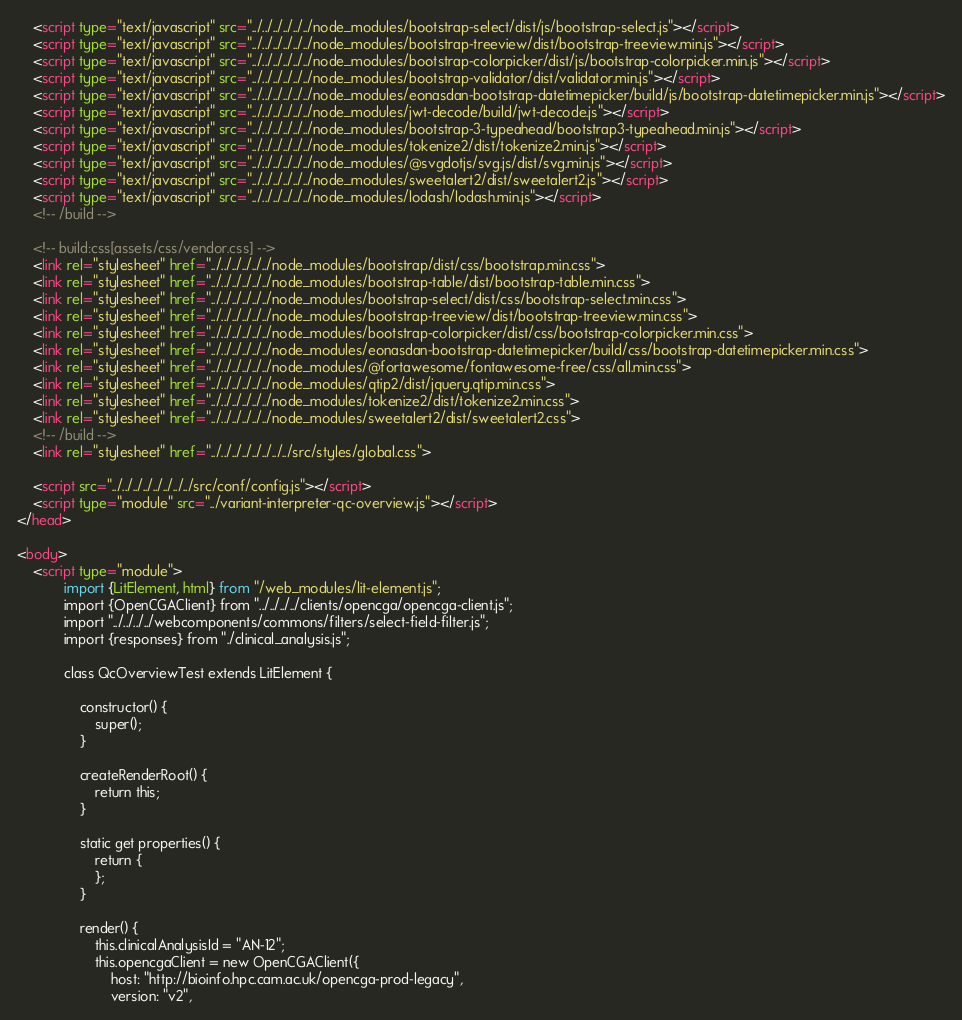Convert code to text. <code><loc_0><loc_0><loc_500><loc_500><_HTML_>    <script type="text/javascript" src="../../../../../../node_modules/bootstrap-select/dist/js/bootstrap-select.js"></script>
    <script type="text/javascript" src="../../../../../../node_modules/bootstrap-treeview/dist/bootstrap-treeview.min.js"></script>
    <script type="text/javascript" src="../../../../../../node_modules/bootstrap-colorpicker/dist/js/bootstrap-colorpicker.min.js"></script>
    <script type="text/javascript" src="../../../../../../node_modules/bootstrap-validator/dist/validator.min.js"></script>
    <script type="text/javascript" src="../../../../../../node_modules/eonasdan-bootstrap-datetimepicker/build/js/bootstrap-datetimepicker.min.js"></script>
    <script type="text/javascript" src="../../../../../../node_modules/jwt-decode/build/jwt-decode.js"></script>
    <script type="text/javascript" src="../../../../../../node_modules/bootstrap-3-typeahead/bootstrap3-typeahead.min.js"></script>
    <script type="text/javascript" src="../../../../../../node_modules/tokenize2/dist/tokenize2.min.js"></script>
    <script type="text/javascript" src="../../../../../../node_modules/@svgdotjs/svg.js/dist/svg.min.js"></script>
    <script type="text/javascript" src="../../../../../../node_modules/sweetalert2/dist/sweetalert2.js"></script>
    <script type="text/javascript" src="../../../../../../node_modules/lodash/lodash.min.js"></script>
    <!-- /build -->

    <!-- build:css[assets/css/vendor.css] -->
    <link rel="stylesheet" href="../../../../../../node_modules/bootstrap/dist/css/bootstrap.min.css">
    <link rel="stylesheet" href="../../../../../../node_modules/bootstrap-table/dist/bootstrap-table.min.css">
    <link rel="stylesheet" href="../../../../../../node_modules/bootstrap-select/dist/css/bootstrap-select.min.css">
    <link rel="stylesheet" href="../../../../../../node_modules/bootstrap-treeview/dist/bootstrap-treeview.min.css">
    <link rel="stylesheet" href="../../../../../../node_modules/bootstrap-colorpicker/dist/css/bootstrap-colorpicker.min.css">
    <link rel="stylesheet" href="../../../../../../node_modules/eonasdan-bootstrap-datetimepicker/build/css/bootstrap-datetimepicker.min.css">
    <link rel="stylesheet" href="../../../../../../node_modules/@fortawesome/fontawesome-free/css/all.min.css">
    <link rel="stylesheet" href="../../../../../../node_modules/qtip2/dist/jquery.qtip.min.css">
    <link rel="stylesheet" href="../../../../../../node_modules/tokenize2/dist/tokenize2.min.css">
    <link rel="stylesheet" href="../../../../../../node_modules/sweetalert2/dist/sweetalert2.css">
    <!-- /build -->
    <link rel="stylesheet" href="../../../../../../../../src/styles/global.css">

    <script src="../../../../../../../../src/conf/config.js"></script>
    <script type="module" src="../variant-interpreter-qc-overview.js"></script>
</head>

<body>
    <script type="module">
            import {LitElement, html} from "/web_modules/lit-element.js";
            import {OpenCGAClient} from "../../../../clients/opencga/opencga-client.js";
            import "../../../../webcomponents/commons/filters/select-field-filter.js";
            import {responses} from "./clinical_analysis.js";

            class QcOverviewTest extends LitElement {

                constructor() {
                    super();
                }

                createRenderRoot() {
                    return this;
                }

                static get properties() {
                    return {
                    };
                }

                render() {
                    this.clinicalAnalysisId = "AN-12";
                    this.opencgaClient = new OpenCGAClient({
                        host: "http://bioinfo.hpc.cam.ac.uk/opencga-prod-legacy",
                        version: "v2",</code> 